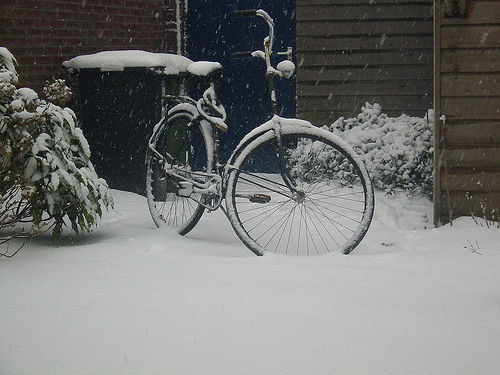How might this image change with the onset of different seasons? In different seasons, the bicycle would emerge from its snowy blanket, possibly surrounded by blossoming flowers in spring, resting under a canopy of lush green leaves in summer, or framed by the warm hues of falling leaves in autumn, each season painting a dramatically different picture. 